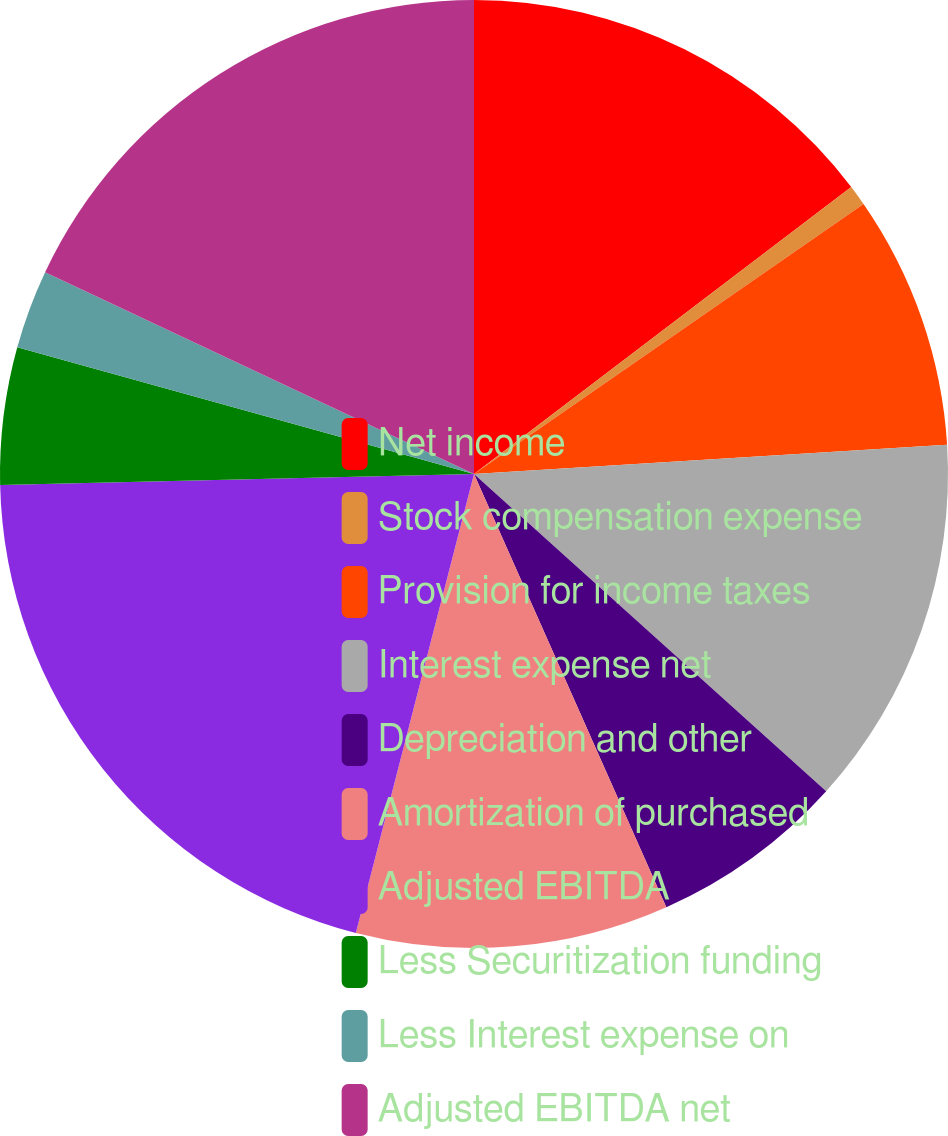Convert chart to OTSL. <chart><loc_0><loc_0><loc_500><loc_500><pie_chart><fcel>Net income<fcel>Stock compensation expense<fcel>Provision for income taxes<fcel>Interest expense net<fcel>Depreciation and other<fcel>Amortization of purchased<fcel>Adjusted EBITDA<fcel>Less Securitization funding<fcel>Less Interest expense on<fcel>Adjusted EBITDA net<nl><fcel>14.65%<fcel>0.7%<fcel>8.67%<fcel>12.65%<fcel>6.68%<fcel>10.66%<fcel>20.62%<fcel>4.68%<fcel>2.69%<fcel>18.0%<nl></chart> 